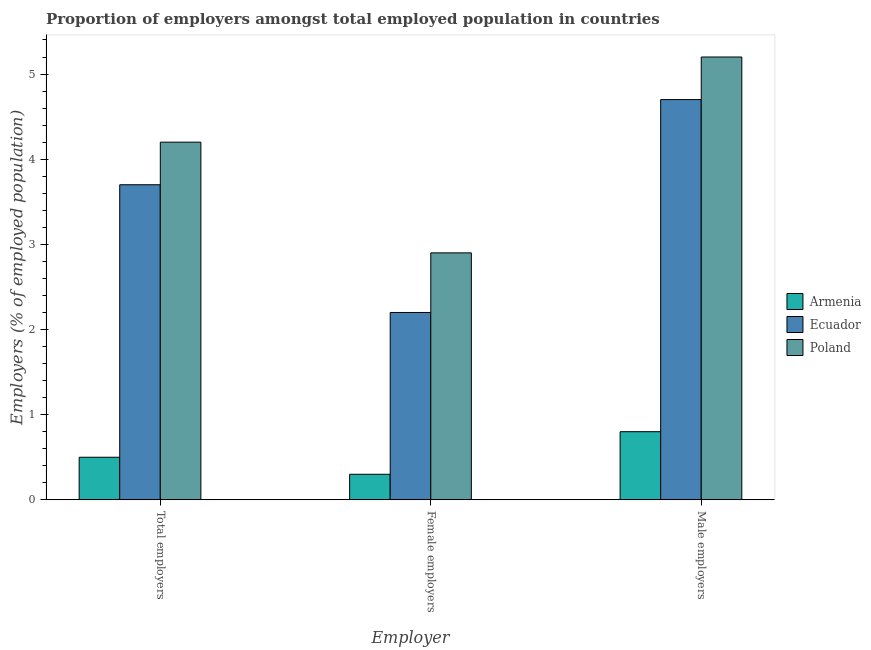How many different coloured bars are there?
Offer a very short reply. 3. How many groups of bars are there?
Your response must be concise. 3. Are the number of bars per tick equal to the number of legend labels?
Your answer should be very brief. Yes. What is the label of the 3rd group of bars from the left?
Your answer should be compact. Male employers. What is the percentage of female employers in Armenia?
Offer a very short reply. 0.3. Across all countries, what is the maximum percentage of male employers?
Give a very brief answer. 5.2. In which country was the percentage of total employers maximum?
Give a very brief answer. Poland. In which country was the percentage of total employers minimum?
Offer a terse response. Armenia. What is the total percentage of female employers in the graph?
Provide a short and direct response. 5.4. What is the difference between the percentage of male employers in Poland and that in Ecuador?
Ensure brevity in your answer.  0.5. What is the difference between the percentage of male employers in Armenia and the percentage of female employers in Ecuador?
Your answer should be compact. -1.4. What is the average percentage of male employers per country?
Offer a terse response. 3.57. What is the difference between the percentage of male employers and percentage of total employers in Poland?
Provide a succinct answer. 1. What is the ratio of the percentage of male employers in Ecuador to that in Armenia?
Your answer should be very brief. 5.87. What is the difference between the highest and the second highest percentage of total employers?
Give a very brief answer. 0.5. What is the difference between the highest and the lowest percentage of female employers?
Your answer should be very brief. 2.6. In how many countries, is the percentage of female employers greater than the average percentage of female employers taken over all countries?
Keep it short and to the point. 2. Is the sum of the percentage of total employers in Armenia and Poland greater than the maximum percentage of male employers across all countries?
Make the answer very short. No. What does the 2nd bar from the right in Male employers represents?
Provide a short and direct response. Ecuador. Are all the bars in the graph horizontal?
Make the answer very short. No. What is the difference between two consecutive major ticks on the Y-axis?
Your answer should be very brief. 1. Does the graph contain any zero values?
Provide a short and direct response. No. Where does the legend appear in the graph?
Your answer should be very brief. Center right. How many legend labels are there?
Give a very brief answer. 3. What is the title of the graph?
Give a very brief answer. Proportion of employers amongst total employed population in countries. Does "Czech Republic" appear as one of the legend labels in the graph?
Your answer should be very brief. No. What is the label or title of the X-axis?
Offer a terse response. Employer. What is the label or title of the Y-axis?
Your answer should be very brief. Employers (% of employed population). What is the Employers (% of employed population) in Armenia in Total employers?
Give a very brief answer. 0.5. What is the Employers (% of employed population) in Ecuador in Total employers?
Give a very brief answer. 3.7. What is the Employers (% of employed population) of Poland in Total employers?
Your response must be concise. 4.2. What is the Employers (% of employed population) of Armenia in Female employers?
Offer a very short reply. 0.3. What is the Employers (% of employed population) of Ecuador in Female employers?
Keep it short and to the point. 2.2. What is the Employers (% of employed population) in Poland in Female employers?
Your answer should be very brief. 2.9. What is the Employers (% of employed population) of Armenia in Male employers?
Offer a terse response. 0.8. What is the Employers (% of employed population) in Ecuador in Male employers?
Your answer should be compact. 4.7. What is the Employers (% of employed population) in Poland in Male employers?
Give a very brief answer. 5.2. Across all Employer, what is the maximum Employers (% of employed population) of Armenia?
Offer a terse response. 0.8. Across all Employer, what is the maximum Employers (% of employed population) of Ecuador?
Your answer should be compact. 4.7. Across all Employer, what is the maximum Employers (% of employed population) of Poland?
Keep it short and to the point. 5.2. Across all Employer, what is the minimum Employers (% of employed population) of Armenia?
Give a very brief answer. 0.3. Across all Employer, what is the minimum Employers (% of employed population) of Ecuador?
Offer a very short reply. 2.2. Across all Employer, what is the minimum Employers (% of employed population) of Poland?
Your answer should be very brief. 2.9. What is the total Employers (% of employed population) of Armenia in the graph?
Provide a succinct answer. 1.6. What is the total Employers (% of employed population) of Ecuador in the graph?
Your response must be concise. 10.6. What is the difference between the Employers (% of employed population) in Ecuador in Total employers and that in Female employers?
Provide a succinct answer. 1.5. What is the difference between the Employers (% of employed population) of Poland in Total employers and that in Female employers?
Give a very brief answer. 1.3. What is the difference between the Employers (% of employed population) in Armenia in Total employers and that in Male employers?
Keep it short and to the point. -0.3. What is the difference between the Employers (% of employed population) in Ecuador in Total employers and that in Male employers?
Offer a terse response. -1. What is the difference between the Employers (% of employed population) of Poland in Total employers and that in Male employers?
Offer a terse response. -1. What is the difference between the Employers (% of employed population) of Poland in Female employers and that in Male employers?
Your answer should be very brief. -2.3. What is the difference between the Employers (% of employed population) in Armenia in Total employers and the Employers (% of employed population) in Ecuador in Female employers?
Offer a terse response. -1.7. What is the difference between the Employers (% of employed population) of Ecuador in Total employers and the Employers (% of employed population) of Poland in Female employers?
Provide a short and direct response. 0.8. What is the difference between the Employers (% of employed population) in Armenia in Total employers and the Employers (% of employed population) in Ecuador in Male employers?
Provide a short and direct response. -4.2. What is the difference between the Employers (% of employed population) of Armenia in Total employers and the Employers (% of employed population) of Poland in Male employers?
Make the answer very short. -4.7. What is the difference between the Employers (% of employed population) of Ecuador in Total employers and the Employers (% of employed population) of Poland in Male employers?
Keep it short and to the point. -1.5. What is the difference between the Employers (% of employed population) of Ecuador in Female employers and the Employers (% of employed population) of Poland in Male employers?
Give a very brief answer. -3. What is the average Employers (% of employed population) of Armenia per Employer?
Give a very brief answer. 0.53. What is the average Employers (% of employed population) in Ecuador per Employer?
Provide a succinct answer. 3.53. What is the difference between the Employers (% of employed population) in Armenia and Employers (% of employed population) in Ecuador in Female employers?
Provide a short and direct response. -1.9. What is the difference between the Employers (% of employed population) of Ecuador and Employers (% of employed population) of Poland in Female employers?
Offer a very short reply. -0.7. What is the difference between the Employers (% of employed population) of Armenia and Employers (% of employed population) of Ecuador in Male employers?
Keep it short and to the point. -3.9. What is the difference between the Employers (% of employed population) in Armenia and Employers (% of employed population) in Poland in Male employers?
Your answer should be very brief. -4.4. What is the ratio of the Employers (% of employed population) in Armenia in Total employers to that in Female employers?
Provide a succinct answer. 1.67. What is the ratio of the Employers (% of employed population) of Ecuador in Total employers to that in Female employers?
Offer a terse response. 1.68. What is the ratio of the Employers (% of employed population) of Poland in Total employers to that in Female employers?
Your response must be concise. 1.45. What is the ratio of the Employers (% of employed population) in Ecuador in Total employers to that in Male employers?
Provide a short and direct response. 0.79. What is the ratio of the Employers (% of employed population) in Poland in Total employers to that in Male employers?
Keep it short and to the point. 0.81. What is the ratio of the Employers (% of employed population) in Armenia in Female employers to that in Male employers?
Keep it short and to the point. 0.38. What is the ratio of the Employers (% of employed population) of Ecuador in Female employers to that in Male employers?
Your answer should be compact. 0.47. What is the ratio of the Employers (% of employed population) in Poland in Female employers to that in Male employers?
Your answer should be very brief. 0.56. What is the difference between the highest and the second highest Employers (% of employed population) of Armenia?
Ensure brevity in your answer.  0.3. What is the difference between the highest and the second highest Employers (% of employed population) in Poland?
Make the answer very short. 1. What is the difference between the highest and the lowest Employers (% of employed population) in Armenia?
Keep it short and to the point. 0.5. What is the difference between the highest and the lowest Employers (% of employed population) of Ecuador?
Your answer should be compact. 2.5. 